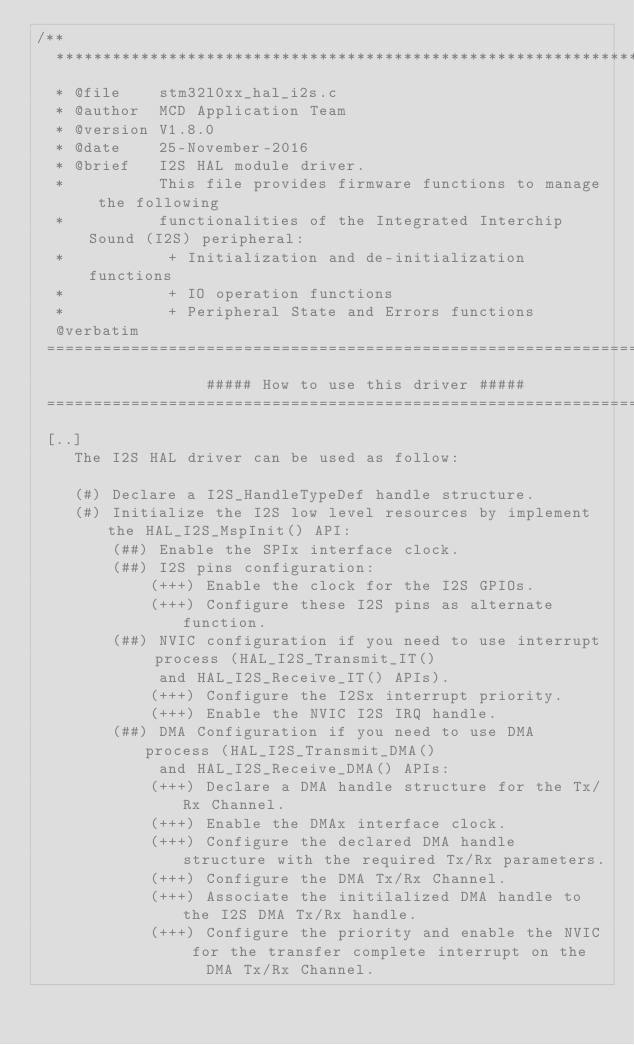<code> <loc_0><loc_0><loc_500><loc_500><_C_>/**
  ******************************************************************************
  * @file    stm32l0xx_hal_i2s.c
  * @author  MCD Application Team
  * @version V1.8.0
  * @date    25-November-2016
  * @brief   I2S HAL module driver.
  *          This file provides firmware functions to manage the following
  *          functionalities of the Integrated Interchip Sound (I2S) peripheral:
  *           + Initialization and de-initialization functions
  *           + IO operation functions
  *           + Peripheral State and Errors functions
  @verbatim
 ===============================================================================
                  ##### How to use this driver #####
 ===============================================================================
 [..]
    The I2S HAL driver can be used as follow:

    (#) Declare a I2S_HandleTypeDef handle structure.
    (#) Initialize the I2S low level resources by implement the HAL_I2S_MspInit() API:
        (##) Enable the SPIx interface clock.
        (##) I2S pins configuration:
            (+++) Enable the clock for the I2S GPIOs.
            (+++) Configure these I2S pins as alternate function.
        (##) NVIC configuration if you need to use interrupt process (HAL_I2S_Transmit_IT()
             and HAL_I2S_Receive_IT() APIs).
            (+++) Configure the I2Sx interrupt priority.
            (+++) Enable the NVIC I2S IRQ handle.
        (##) DMA Configuration if you need to use DMA process (HAL_I2S_Transmit_DMA()
             and HAL_I2S_Receive_DMA() APIs:
            (+++) Declare a DMA handle structure for the Tx/Rx Channel.
            (+++) Enable the DMAx interface clock.
            (+++) Configure the declared DMA handle structure with the required Tx/Rx parameters.
            (+++) Configure the DMA Tx/Rx Channel.
            (+++) Associate the initilalized DMA handle to the I2S DMA Tx/Rx handle.
            (+++) Configure the priority and enable the NVIC for the transfer complete interrupt on the
                  DMA Tx/Rx Channel.
</code> 